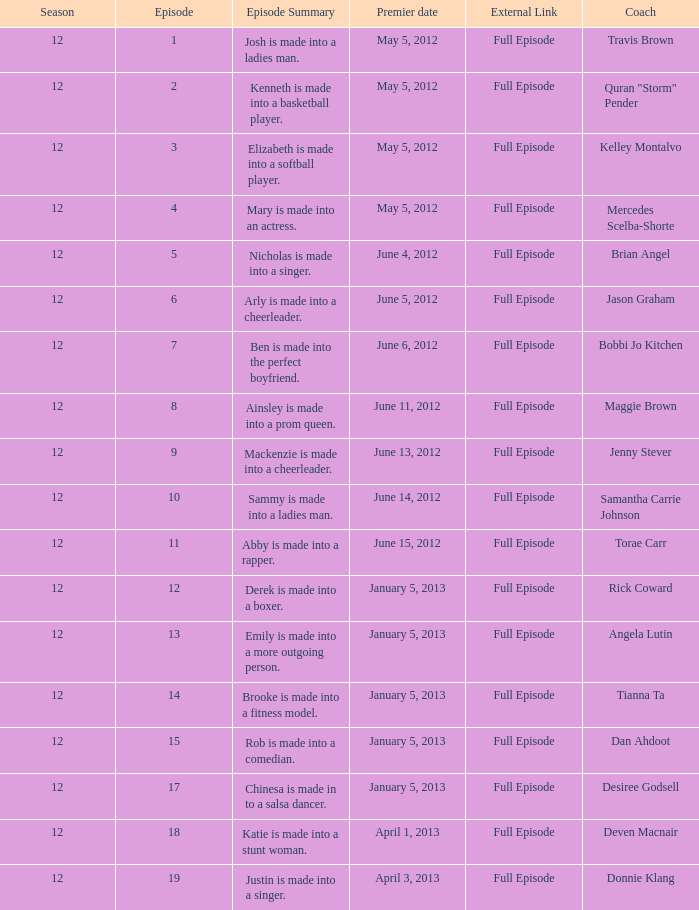Name the episode for travis brown 1.0. 